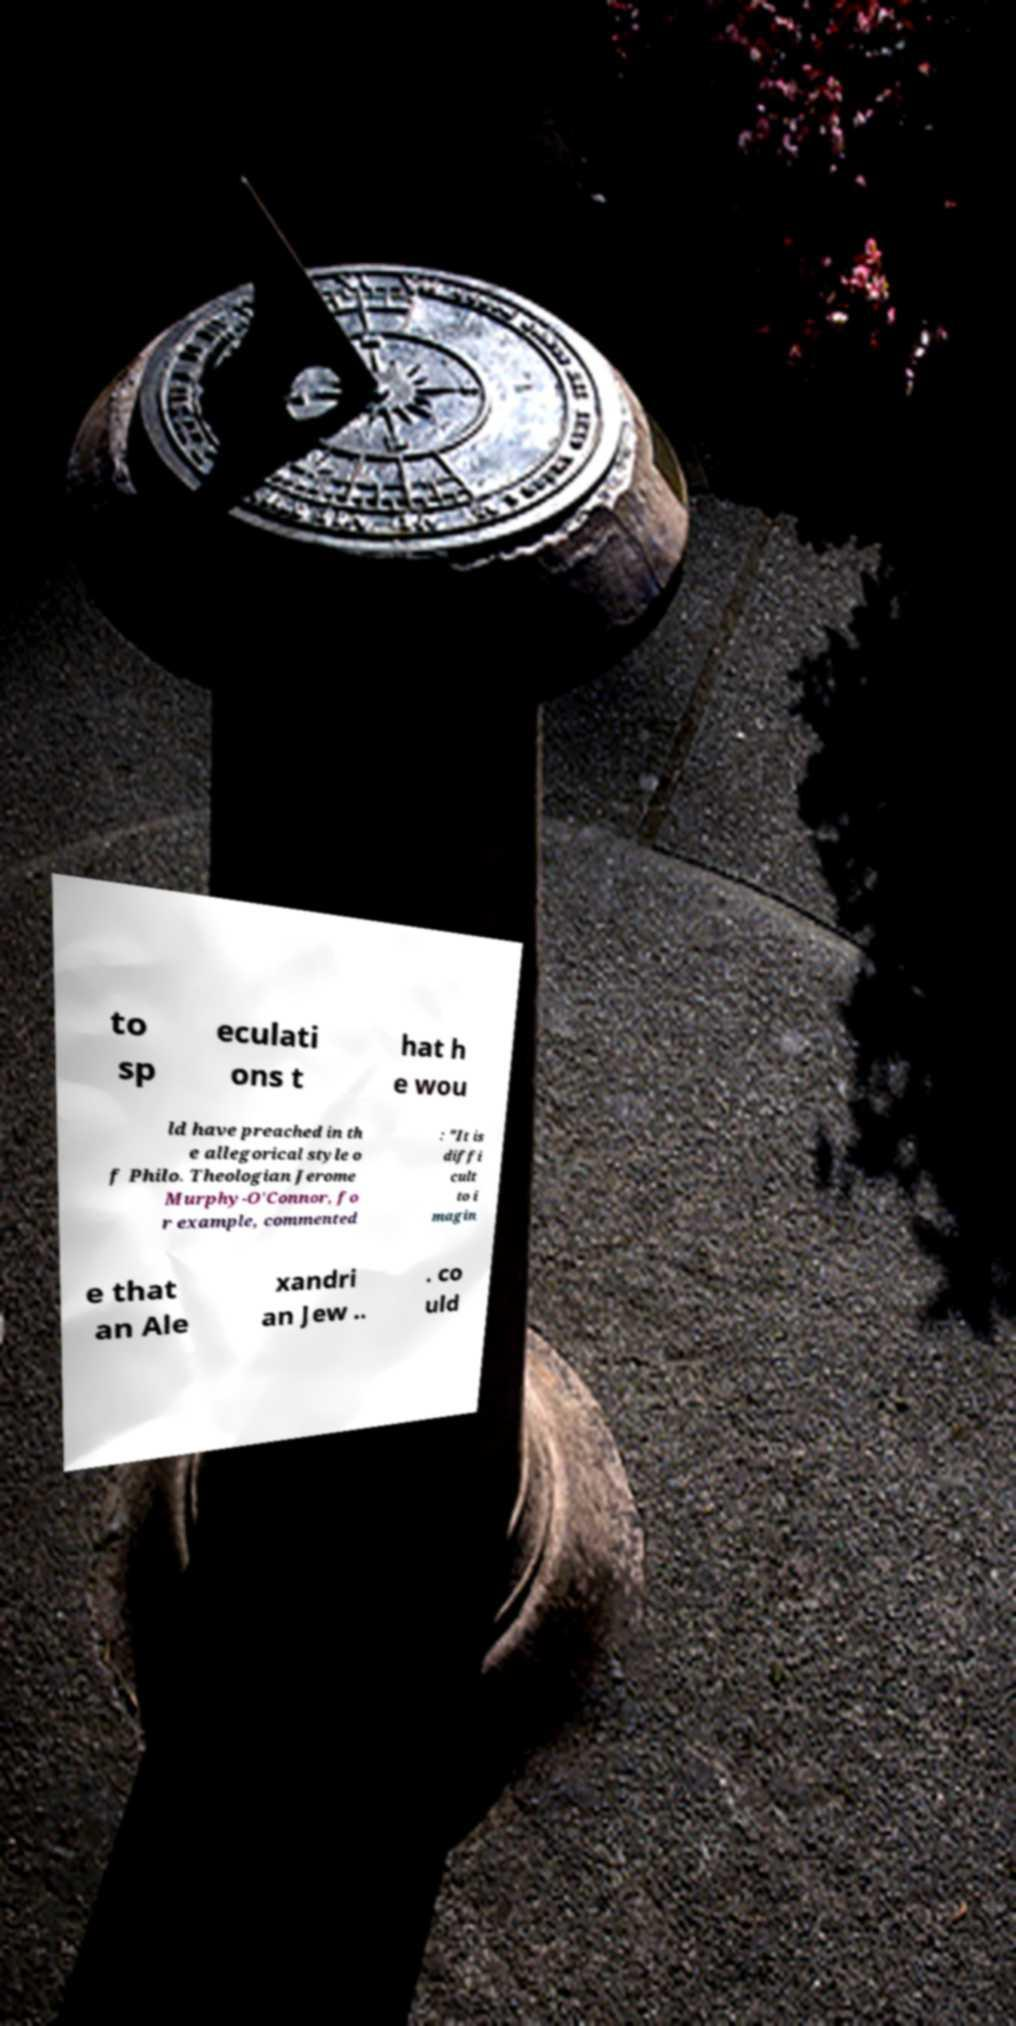Please identify and transcribe the text found in this image. to sp eculati ons t hat h e wou ld have preached in th e allegorical style o f Philo. Theologian Jerome Murphy-O'Connor, fo r example, commented : "It is diffi cult to i magin e that an Ale xandri an Jew .. . co uld 